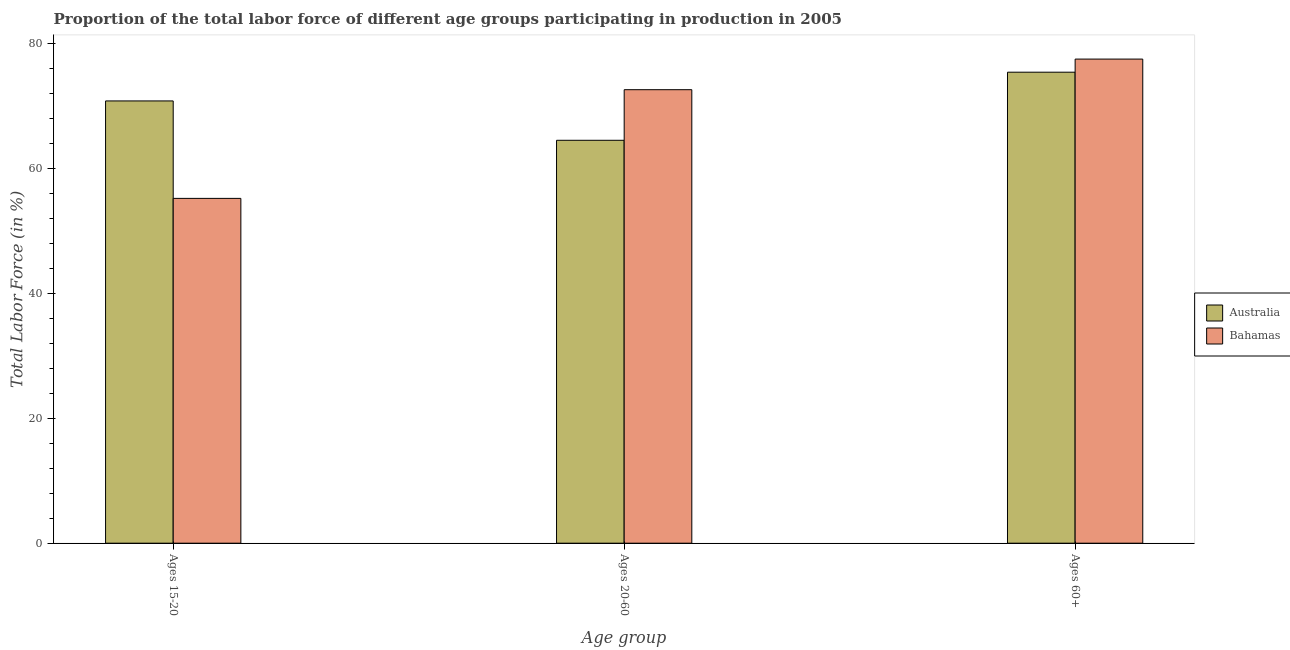How many different coloured bars are there?
Your answer should be compact. 2. How many groups of bars are there?
Offer a terse response. 3. How many bars are there on the 3rd tick from the right?
Offer a terse response. 2. What is the label of the 2nd group of bars from the left?
Provide a succinct answer. Ages 20-60. What is the percentage of labor force above age 60 in Australia?
Your answer should be very brief. 75.4. Across all countries, what is the maximum percentage of labor force within the age group 15-20?
Keep it short and to the point. 70.8. Across all countries, what is the minimum percentage of labor force within the age group 15-20?
Provide a short and direct response. 55.2. In which country was the percentage of labor force within the age group 20-60 minimum?
Provide a short and direct response. Australia. What is the total percentage of labor force within the age group 20-60 in the graph?
Offer a terse response. 137.1. What is the difference between the percentage of labor force within the age group 20-60 in Australia and that in Bahamas?
Your response must be concise. -8.1. What is the difference between the percentage of labor force above age 60 in Bahamas and the percentage of labor force within the age group 15-20 in Australia?
Ensure brevity in your answer.  6.7. What is the average percentage of labor force above age 60 per country?
Provide a succinct answer. 76.45. What is the difference between the percentage of labor force within the age group 20-60 and percentage of labor force within the age group 15-20 in Bahamas?
Provide a short and direct response. 17.4. What is the ratio of the percentage of labor force within the age group 20-60 in Australia to that in Bahamas?
Your answer should be compact. 0.89. Is the percentage of labor force within the age group 20-60 in Bahamas less than that in Australia?
Offer a very short reply. No. What is the difference between the highest and the second highest percentage of labor force within the age group 20-60?
Offer a very short reply. 8.1. What is the difference between the highest and the lowest percentage of labor force within the age group 15-20?
Ensure brevity in your answer.  15.6. In how many countries, is the percentage of labor force above age 60 greater than the average percentage of labor force above age 60 taken over all countries?
Ensure brevity in your answer.  1. What does the 2nd bar from the left in Ages 15-20 represents?
Give a very brief answer. Bahamas. What does the 1st bar from the right in Ages 15-20 represents?
Offer a very short reply. Bahamas. Is it the case that in every country, the sum of the percentage of labor force within the age group 15-20 and percentage of labor force within the age group 20-60 is greater than the percentage of labor force above age 60?
Your response must be concise. Yes. How many bars are there?
Offer a terse response. 6. Are all the bars in the graph horizontal?
Your answer should be compact. No. What is the difference between two consecutive major ticks on the Y-axis?
Offer a very short reply. 20. Are the values on the major ticks of Y-axis written in scientific E-notation?
Provide a succinct answer. No. Does the graph contain any zero values?
Keep it short and to the point. No. Does the graph contain grids?
Ensure brevity in your answer.  No. What is the title of the graph?
Keep it short and to the point. Proportion of the total labor force of different age groups participating in production in 2005. Does "Israel" appear as one of the legend labels in the graph?
Provide a succinct answer. No. What is the label or title of the X-axis?
Make the answer very short. Age group. What is the Total Labor Force (in %) in Australia in Ages 15-20?
Provide a short and direct response. 70.8. What is the Total Labor Force (in %) of Bahamas in Ages 15-20?
Ensure brevity in your answer.  55.2. What is the Total Labor Force (in %) in Australia in Ages 20-60?
Give a very brief answer. 64.5. What is the Total Labor Force (in %) of Bahamas in Ages 20-60?
Provide a succinct answer. 72.6. What is the Total Labor Force (in %) of Australia in Ages 60+?
Offer a very short reply. 75.4. What is the Total Labor Force (in %) in Bahamas in Ages 60+?
Provide a short and direct response. 77.5. Across all Age group, what is the maximum Total Labor Force (in %) in Australia?
Offer a terse response. 75.4. Across all Age group, what is the maximum Total Labor Force (in %) of Bahamas?
Your response must be concise. 77.5. Across all Age group, what is the minimum Total Labor Force (in %) in Australia?
Your answer should be very brief. 64.5. Across all Age group, what is the minimum Total Labor Force (in %) of Bahamas?
Give a very brief answer. 55.2. What is the total Total Labor Force (in %) of Australia in the graph?
Provide a succinct answer. 210.7. What is the total Total Labor Force (in %) in Bahamas in the graph?
Give a very brief answer. 205.3. What is the difference between the Total Labor Force (in %) in Australia in Ages 15-20 and that in Ages 20-60?
Give a very brief answer. 6.3. What is the difference between the Total Labor Force (in %) of Bahamas in Ages 15-20 and that in Ages 20-60?
Ensure brevity in your answer.  -17.4. What is the difference between the Total Labor Force (in %) in Bahamas in Ages 15-20 and that in Ages 60+?
Keep it short and to the point. -22.3. What is the difference between the Total Labor Force (in %) in Bahamas in Ages 20-60 and that in Ages 60+?
Make the answer very short. -4.9. What is the difference between the Total Labor Force (in %) in Australia in Ages 15-20 and the Total Labor Force (in %) in Bahamas in Ages 60+?
Your answer should be compact. -6.7. What is the difference between the Total Labor Force (in %) in Australia in Ages 20-60 and the Total Labor Force (in %) in Bahamas in Ages 60+?
Offer a terse response. -13. What is the average Total Labor Force (in %) in Australia per Age group?
Keep it short and to the point. 70.23. What is the average Total Labor Force (in %) in Bahamas per Age group?
Your answer should be very brief. 68.43. What is the difference between the Total Labor Force (in %) in Australia and Total Labor Force (in %) in Bahamas in Ages 15-20?
Your response must be concise. 15.6. What is the ratio of the Total Labor Force (in %) of Australia in Ages 15-20 to that in Ages 20-60?
Make the answer very short. 1.1. What is the ratio of the Total Labor Force (in %) in Bahamas in Ages 15-20 to that in Ages 20-60?
Offer a terse response. 0.76. What is the ratio of the Total Labor Force (in %) in Australia in Ages 15-20 to that in Ages 60+?
Offer a terse response. 0.94. What is the ratio of the Total Labor Force (in %) in Bahamas in Ages 15-20 to that in Ages 60+?
Offer a very short reply. 0.71. What is the ratio of the Total Labor Force (in %) in Australia in Ages 20-60 to that in Ages 60+?
Give a very brief answer. 0.86. What is the ratio of the Total Labor Force (in %) of Bahamas in Ages 20-60 to that in Ages 60+?
Offer a very short reply. 0.94. What is the difference between the highest and the second highest Total Labor Force (in %) in Bahamas?
Make the answer very short. 4.9. What is the difference between the highest and the lowest Total Labor Force (in %) of Bahamas?
Keep it short and to the point. 22.3. 